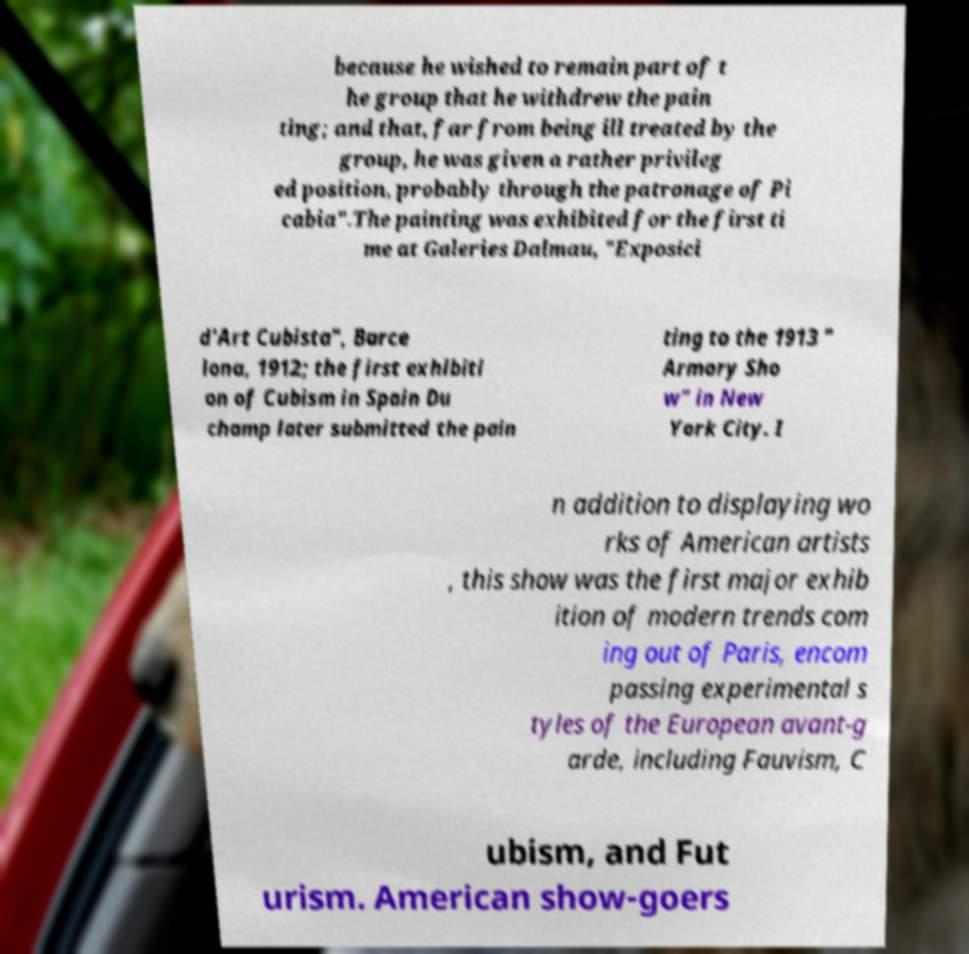What messages or text are displayed in this image? I need them in a readable, typed format. because he wished to remain part of t he group that he withdrew the pain ting; and that, far from being ill treated by the group, he was given a rather privileg ed position, probably through the patronage of Pi cabia".The painting was exhibited for the first ti me at Galeries Dalmau, "Exposici d'Art Cubista", Barce lona, 1912; the first exhibiti on of Cubism in Spain Du champ later submitted the pain ting to the 1913 " Armory Sho w" in New York City. I n addition to displaying wo rks of American artists , this show was the first major exhib ition of modern trends com ing out of Paris, encom passing experimental s tyles of the European avant-g arde, including Fauvism, C ubism, and Fut urism. American show-goers 